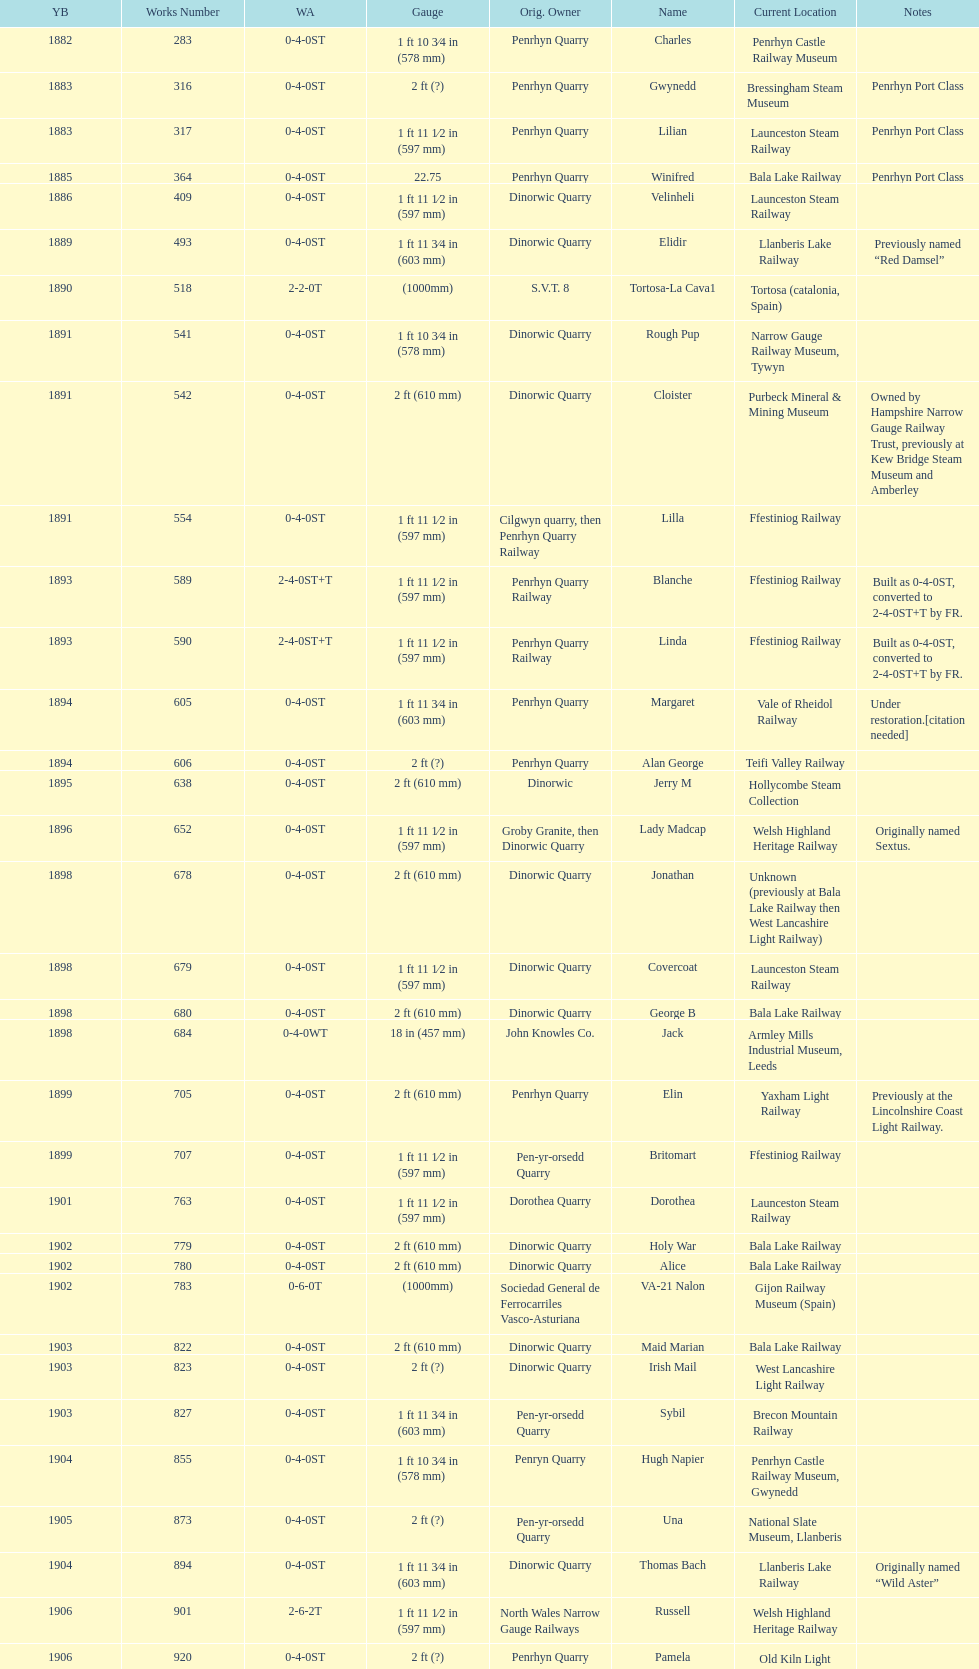Aside from 316, what was the other works number used in 1883? 317. 